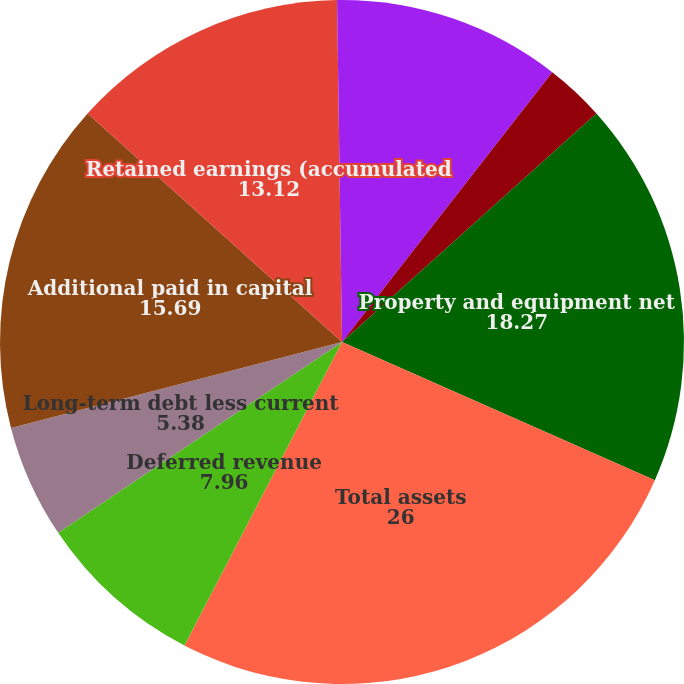<chart> <loc_0><loc_0><loc_500><loc_500><pie_chart><fcel>Cash and cash equivalents<fcel>Working capital (deficit) (3)<fcel>Property and equipment net<fcel>Total assets<fcel>Deferred revenue<fcel>Long-term debt less current<fcel>Additional paid in capital<fcel>Retained earnings (accumulated<fcel>Total stockholder's equity<nl><fcel>10.54%<fcel>2.81%<fcel>18.27%<fcel>26.0%<fcel>7.96%<fcel>5.38%<fcel>15.69%<fcel>13.12%<fcel>0.23%<nl></chart> 